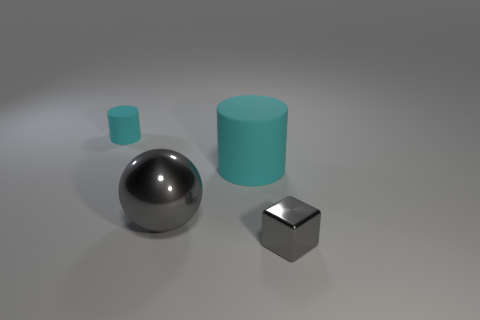Add 4 small brown blocks. How many objects exist? 8 Subtract all cubes. How many objects are left? 3 Subtract all big cyan cylinders. Subtract all cylinders. How many objects are left? 1 Add 2 large gray metallic balls. How many large gray metallic balls are left? 3 Add 1 big cyan shiny objects. How many big cyan shiny objects exist? 1 Subtract 0 cyan spheres. How many objects are left? 4 